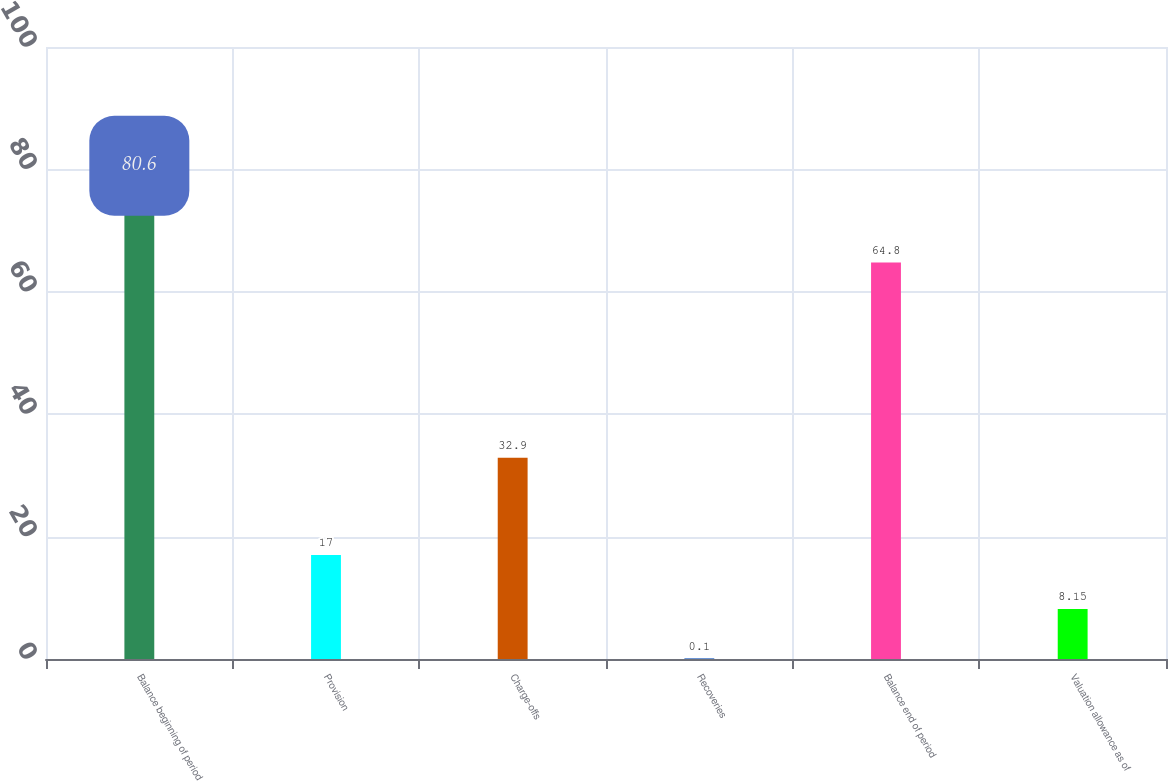<chart> <loc_0><loc_0><loc_500><loc_500><bar_chart><fcel>Balance beginning of period<fcel>Provision<fcel>Charge-offs<fcel>Recoveries<fcel>Balance end of period<fcel>Valuation allowance as of<nl><fcel>80.6<fcel>17<fcel>32.9<fcel>0.1<fcel>64.8<fcel>8.15<nl></chart> 